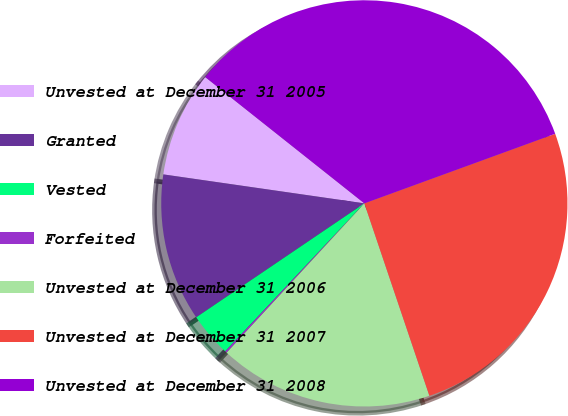Convert chart to OTSL. <chart><loc_0><loc_0><loc_500><loc_500><pie_chart><fcel>Unvested at December 31 2005<fcel>Granted<fcel>Vested<fcel>Forfeited<fcel>Unvested at December 31 2006<fcel>Unvested at December 31 2007<fcel>Unvested at December 31 2008<nl><fcel>8.4%<fcel>11.76%<fcel>3.51%<fcel>0.15%<fcel>17.05%<fcel>25.38%<fcel>33.76%<nl></chart> 